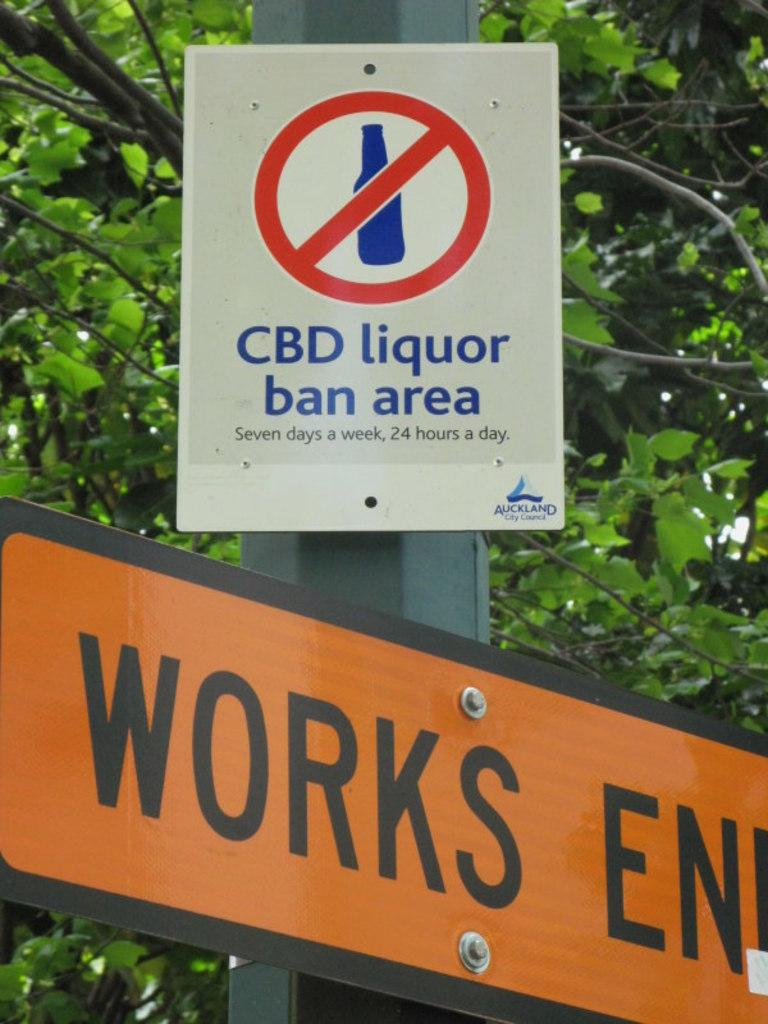<image>
Create a compact narrative representing the image presented. A white sign says CBD liquor ban area and there are trees behind it. 